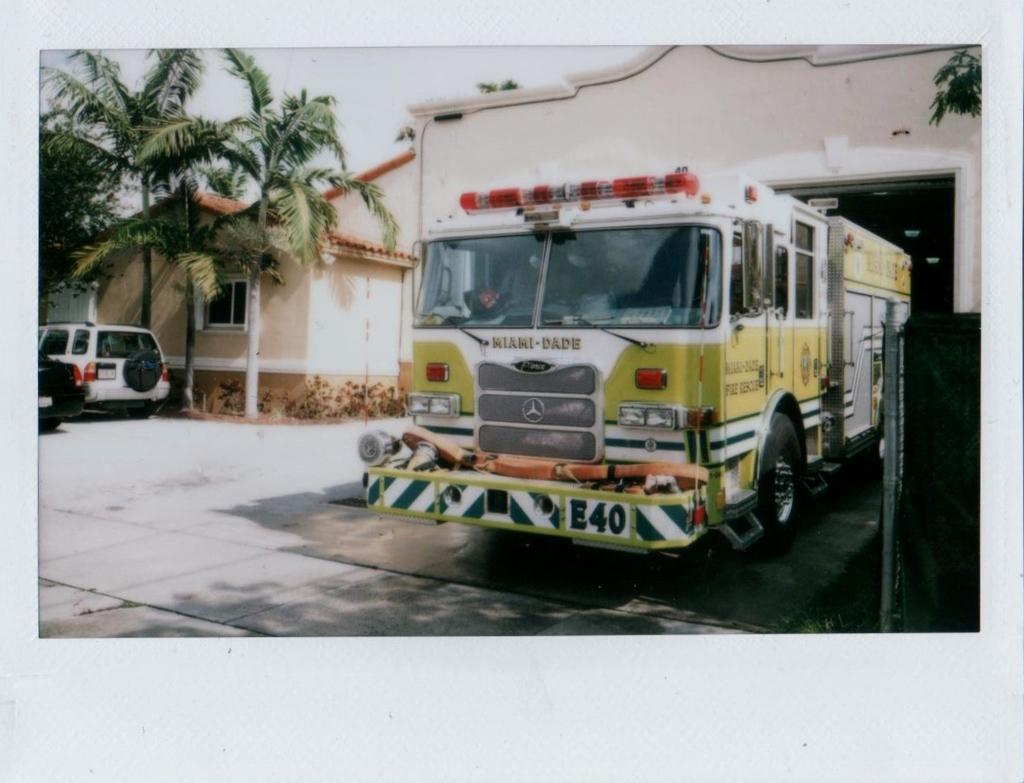Please provide a concise description of this image. There is a vehicle in the foreground area of the image, there are vehicles, trees, house structure and the sky in the background. 